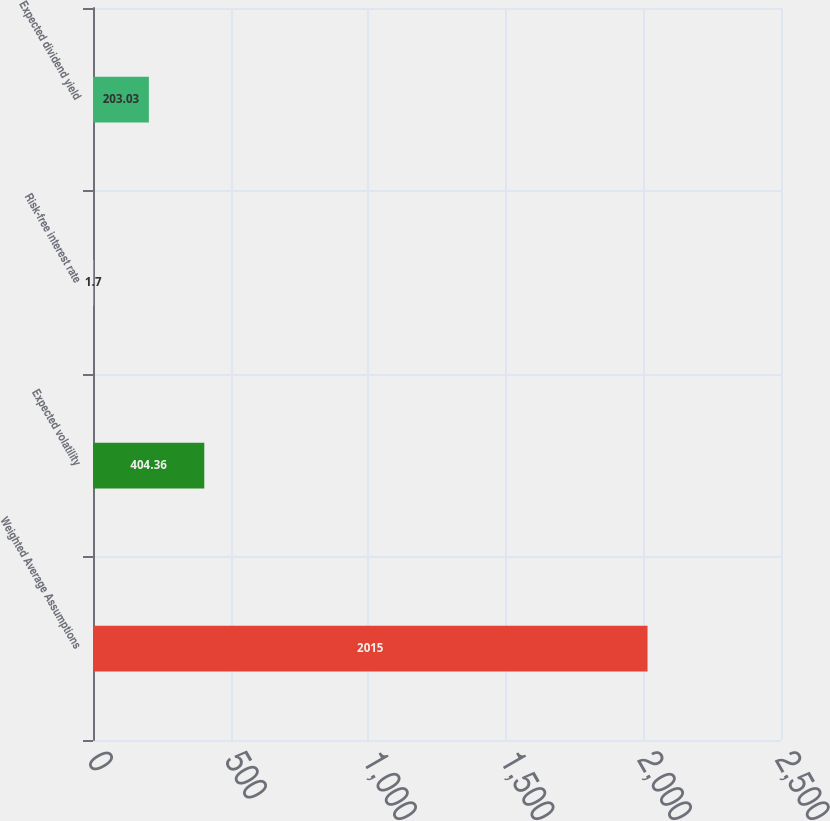Convert chart. <chart><loc_0><loc_0><loc_500><loc_500><bar_chart><fcel>Weighted Average Assumptions<fcel>Expected volatility<fcel>Risk-free interest rate<fcel>Expected dividend yield<nl><fcel>2015<fcel>404.36<fcel>1.7<fcel>203.03<nl></chart> 